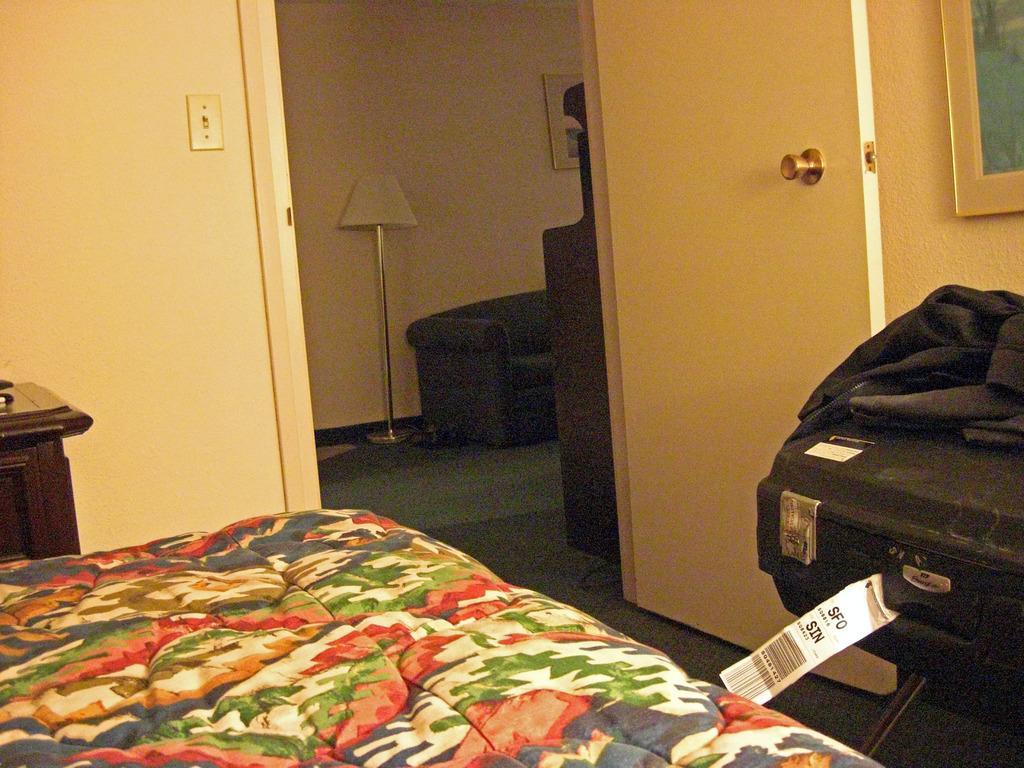Please provide a concise description of this image. In this image we can see a bed, table, suitcase, cloth door, window, there is a lamp, photo frame on the wall, also we can see a card with some text on it. 